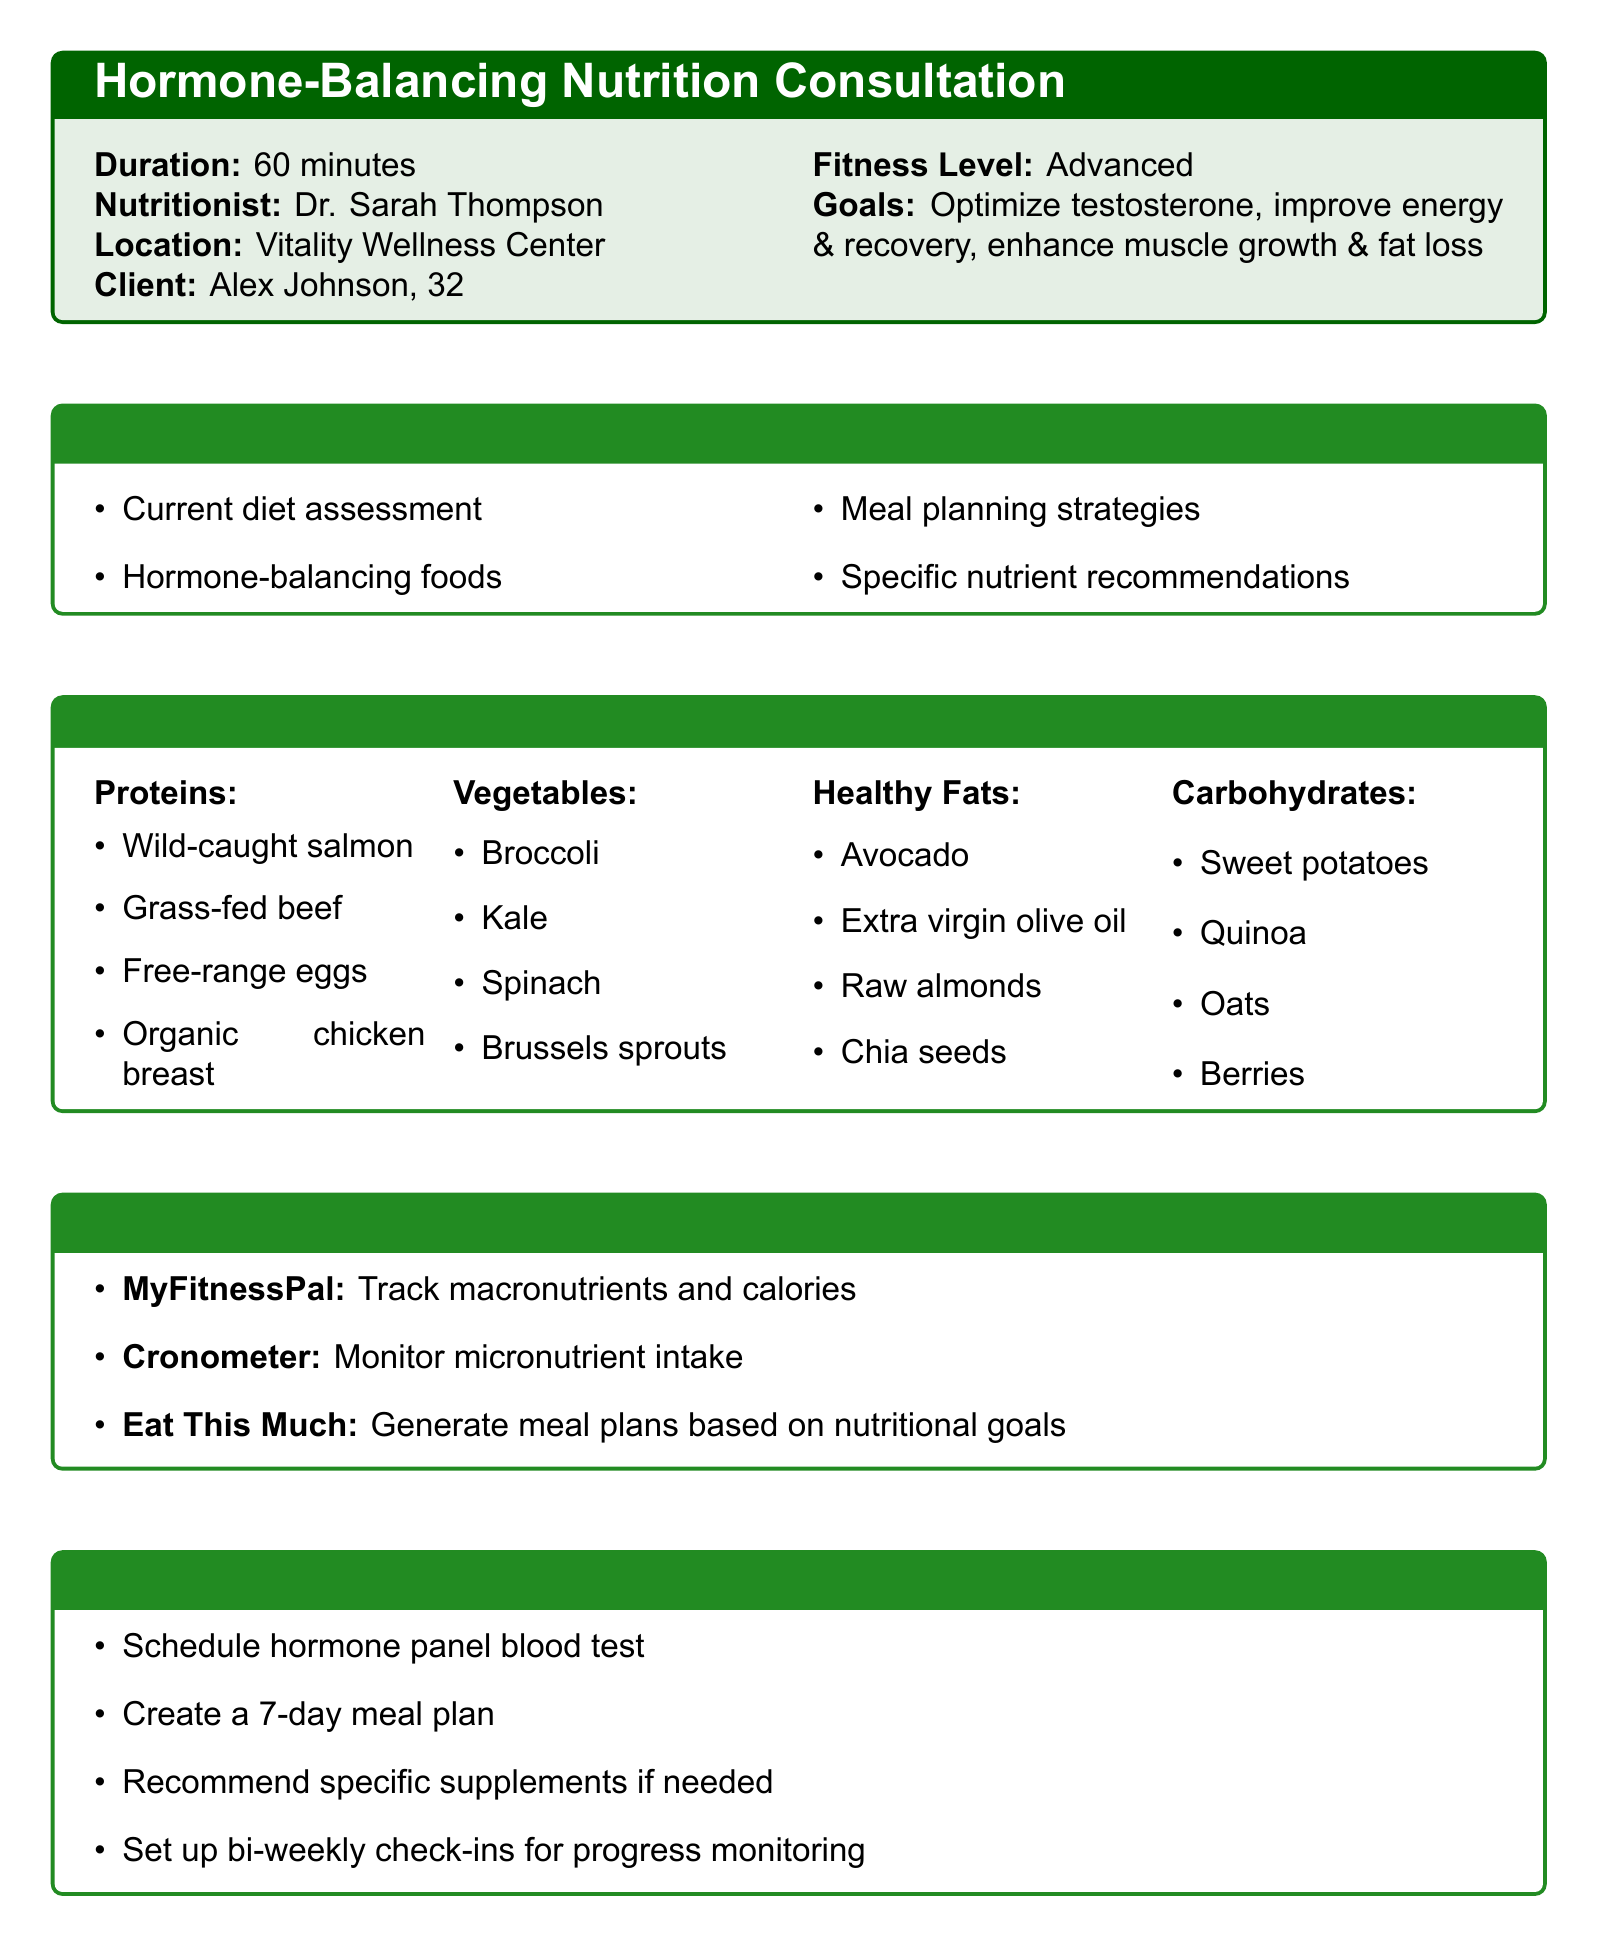What is the duration of the consultation? The duration of the consultation is specified in the document.
Answer: 60 minutes Who is the nutritionist? The document names the nutritionist who will conduct the consultation.
Answer: Dr. Sarah Thompson What is one of Alex's goals? The document lists the client's goals for the consultation.
Answer: Optimize testosterone levels What tool is recommended for tracking macronutrients? The document lists various meal planning tools and their purposes.
Answer: MyFitnessPal Which food category includes broccoli? The recommended foods section organizes items by categories.
Answer: Vegetables What specific nutrient is recommended for testosterone optimization? The document discusses specific nutrients and their benefits related to hormones.
Answer: Magnesium What should be scheduled as a follow-up action? The document outlines follow-up actions to be taken after the consultation.
Answer: Schedule hormone panel blood test Name one supplement that may be recommended. The document implies potential supplements that could be sought based on needs.
Answer: Specific supplements What is the fitness level of the client? The document describes the client’s fitness level.
Answer: Advanced 